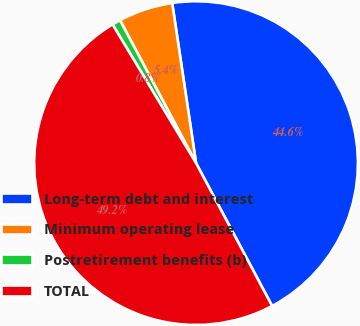Convert chart. <chart><loc_0><loc_0><loc_500><loc_500><pie_chart><fcel>Long-term debt and interest<fcel>Minimum operating lease<fcel>Postretirement benefits (b)<fcel>TOTAL<nl><fcel>44.57%<fcel>5.43%<fcel>0.84%<fcel>49.16%<nl></chart> 